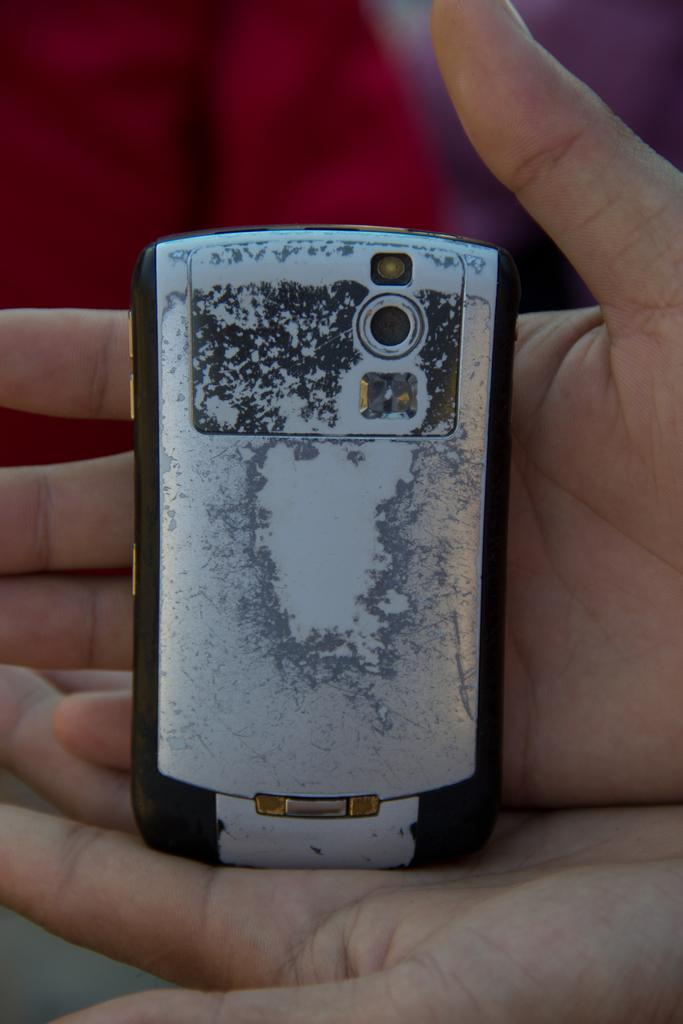What object is being held by someone in the image? There is a mobile in the image, and it is being held by someone. Can you describe the background of the image? The background of the image is blurred. What type of vacation is being planned by the person holding the dime in the image? There is no dime present in the image, and therefore no vacation planning can be observed. 